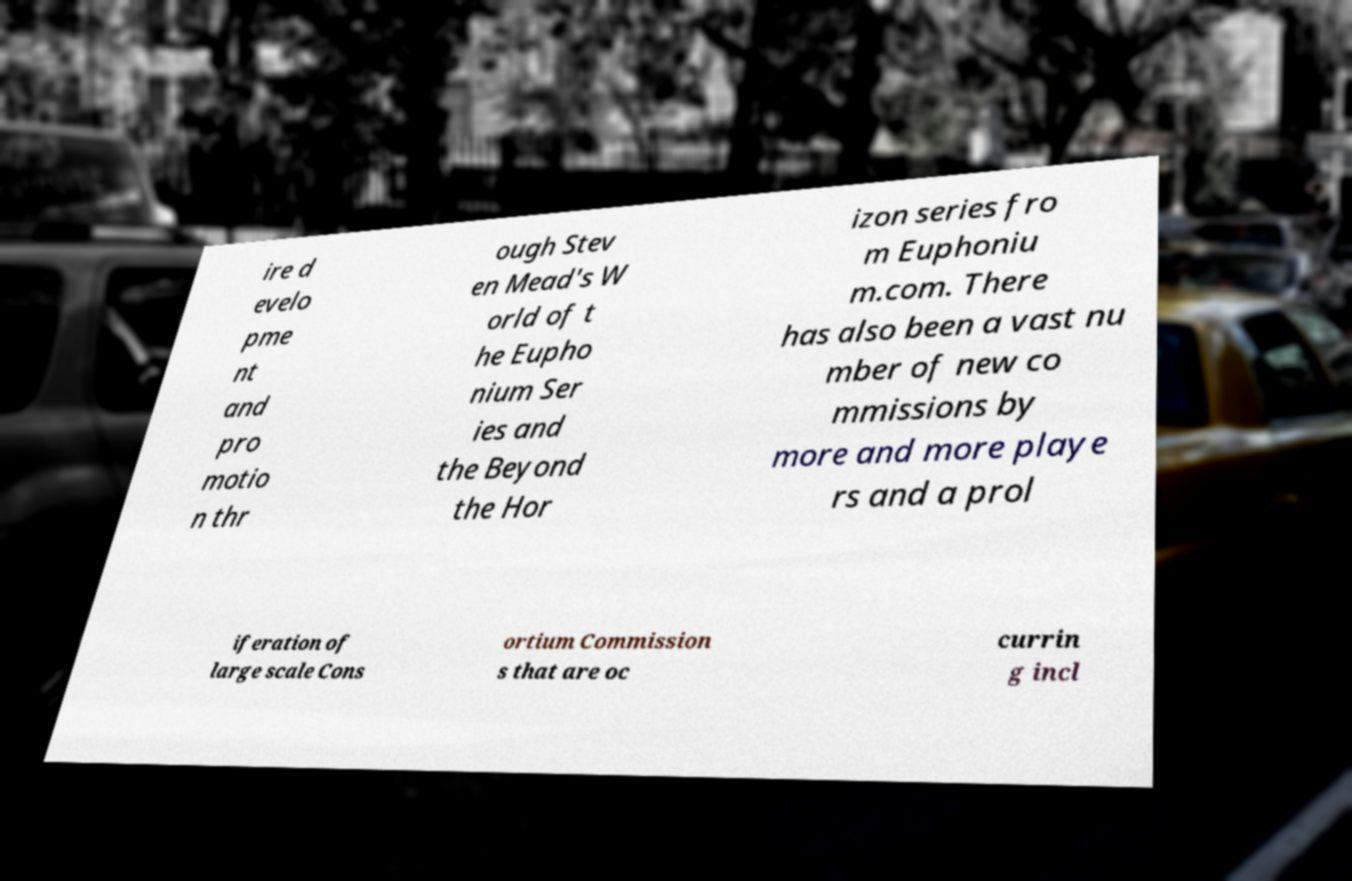Please identify and transcribe the text found in this image. ire d evelo pme nt and pro motio n thr ough Stev en Mead's W orld of t he Eupho nium Ser ies and the Beyond the Hor izon series fro m Euphoniu m.com. There has also been a vast nu mber of new co mmissions by more and more playe rs and a prol iferation of large scale Cons ortium Commission s that are oc currin g incl 